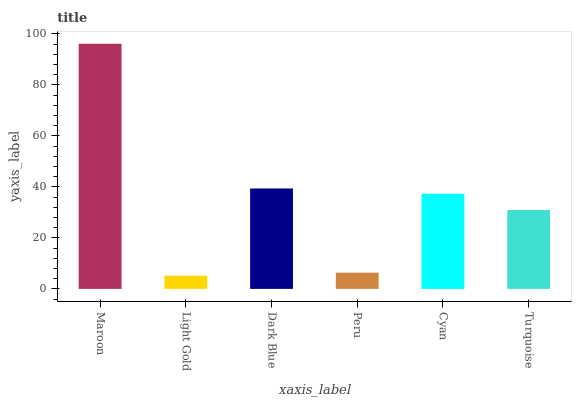Is Light Gold the minimum?
Answer yes or no. Yes. Is Maroon the maximum?
Answer yes or no. Yes. Is Dark Blue the minimum?
Answer yes or no. No. Is Dark Blue the maximum?
Answer yes or no. No. Is Dark Blue greater than Light Gold?
Answer yes or no. Yes. Is Light Gold less than Dark Blue?
Answer yes or no. Yes. Is Light Gold greater than Dark Blue?
Answer yes or no. No. Is Dark Blue less than Light Gold?
Answer yes or no. No. Is Cyan the high median?
Answer yes or no. Yes. Is Turquoise the low median?
Answer yes or no. Yes. Is Peru the high median?
Answer yes or no. No. Is Peru the low median?
Answer yes or no. No. 